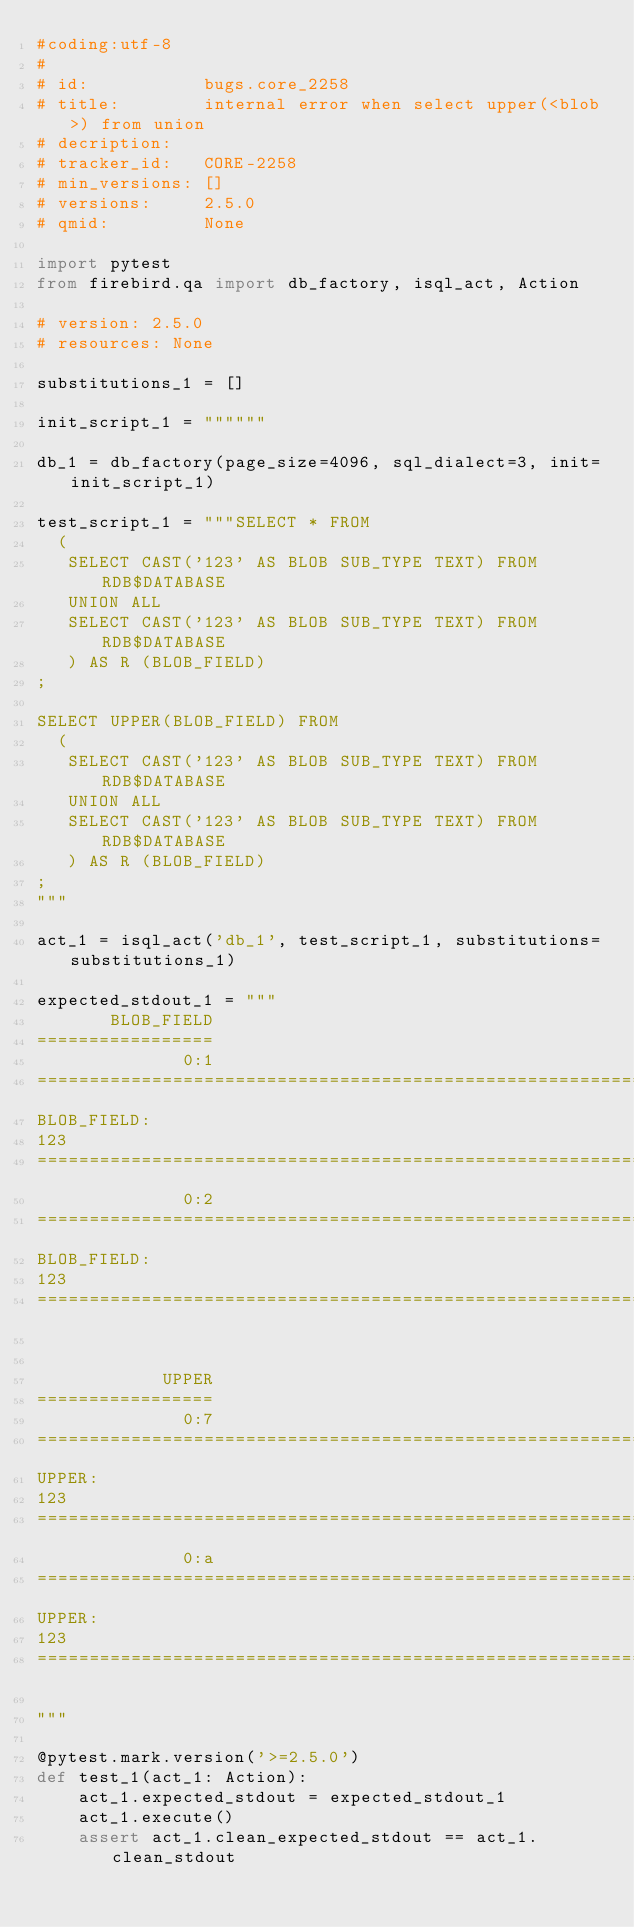Convert code to text. <code><loc_0><loc_0><loc_500><loc_500><_Python_>#coding:utf-8
#
# id:           bugs.core_2258
# title:        internal error when select upper(<blob>) from union
# decription:   
# tracker_id:   CORE-2258
# min_versions: []
# versions:     2.5.0
# qmid:         None

import pytest
from firebird.qa import db_factory, isql_act, Action

# version: 2.5.0
# resources: None

substitutions_1 = []

init_script_1 = """"""

db_1 = db_factory(page_size=4096, sql_dialect=3, init=init_script_1)

test_script_1 = """SELECT * FROM
  (
   SELECT CAST('123' AS BLOB SUB_TYPE TEXT) FROM RDB$DATABASE
   UNION ALL
   SELECT CAST('123' AS BLOB SUB_TYPE TEXT) FROM RDB$DATABASE
   ) AS R (BLOB_FIELD)
;

SELECT UPPER(BLOB_FIELD) FROM
  (
   SELECT CAST('123' AS BLOB SUB_TYPE TEXT) FROM RDB$DATABASE
   UNION ALL
   SELECT CAST('123' AS BLOB SUB_TYPE TEXT) FROM RDB$DATABASE
   ) AS R (BLOB_FIELD)
;
"""

act_1 = isql_act('db_1', test_script_1, substitutions=substitutions_1)

expected_stdout_1 = """
       BLOB_FIELD
=================
              0:1
==============================================================================
BLOB_FIELD:
123
==============================================================================
              0:2
==============================================================================
BLOB_FIELD:
123
==============================================================================


            UPPER
=================
              0:7
==============================================================================
UPPER:
123
==============================================================================
              0:a
==============================================================================
UPPER:
123
==============================================================================

"""

@pytest.mark.version('>=2.5.0')
def test_1(act_1: Action):
    act_1.expected_stdout = expected_stdout_1
    act_1.execute()
    assert act_1.clean_expected_stdout == act_1.clean_stdout

</code> 